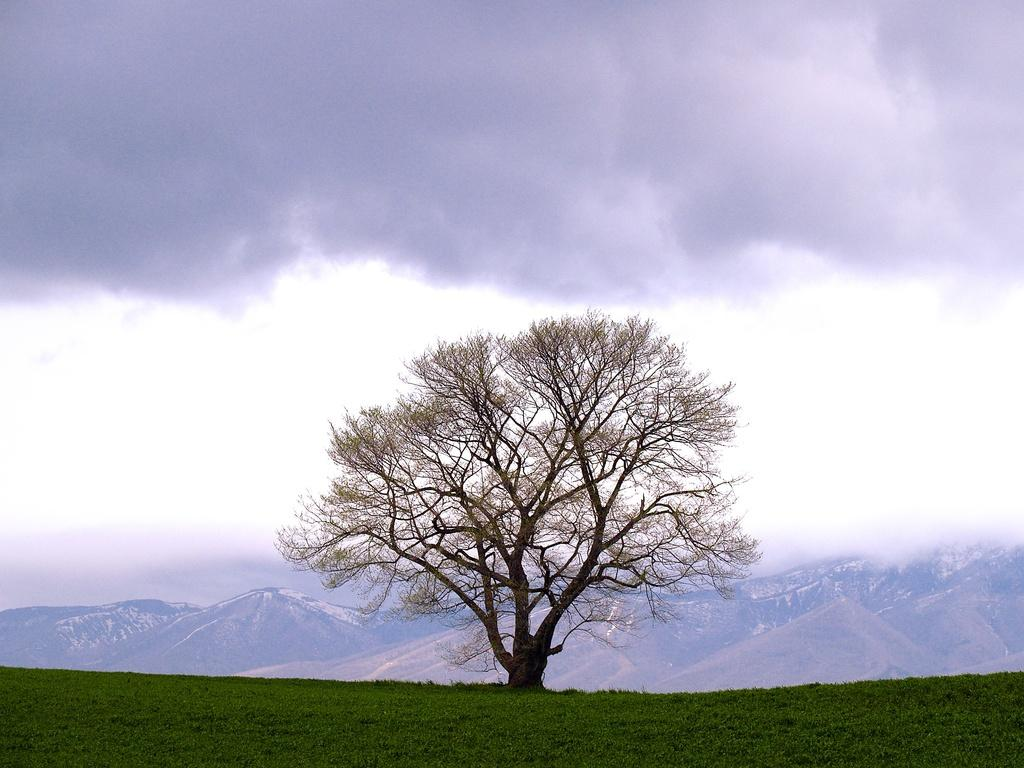What type of vegetation is present in the image? There is a tree and grass on the ground in the image. What can be seen in the background of the image? There are hills visible in the image. How would you describe the sky in the image? The sky is cloudy in the image. What type of rice is being cooked in the image? There is no rice present in the image; it features a tree, grass, hills, and a cloudy sky. Can you see a loaf of bread in the image? There is no loaf of bread present in the image. 